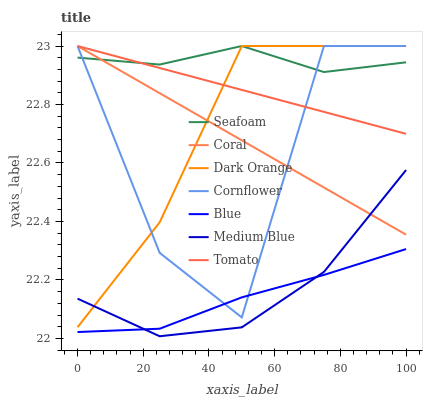Does Blue have the minimum area under the curve?
Answer yes or no. Yes. Does Seafoam have the maximum area under the curve?
Answer yes or no. Yes. Does Dark Orange have the minimum area under the curve?
Answer yes or no. No. Does Dark Orange have the maximum area under the curve?
Answer yes or no. No. Is Tomato the smoothest?
Answer yes or no. Yes. Is Cornflower the roughest?
Answer yes or no. Yes. Is Dark Orange the smoothest?
Answer yes or no. No. Is Dark Orange the roughest?
Answer yes or no. No. Does Medium Blue have the lowest value?
Answer yes or no. Yes. Does Dark Orange have the lowest value?
Answer yes or no. No. Does Tomato have the highest value?
Answer yes or no. Yes. Does Medium Blue have the highest value?
Answer yes or no. No. Is Medium Blue less than Seafoam?
Answer yes or no. Yes. Is Tomato greater than Blue?
Answer yes or no. Yes. Does Dark Orange intersect Coral?
Answer yes or no. Yes. Is Dark Orange less than Coral?
Answer yes or no. No. Is Dark Orange greater than Coral?
Answer yes or no. No. Does Medium Blue intersect Seafoam?
Answer yes or no. No. 